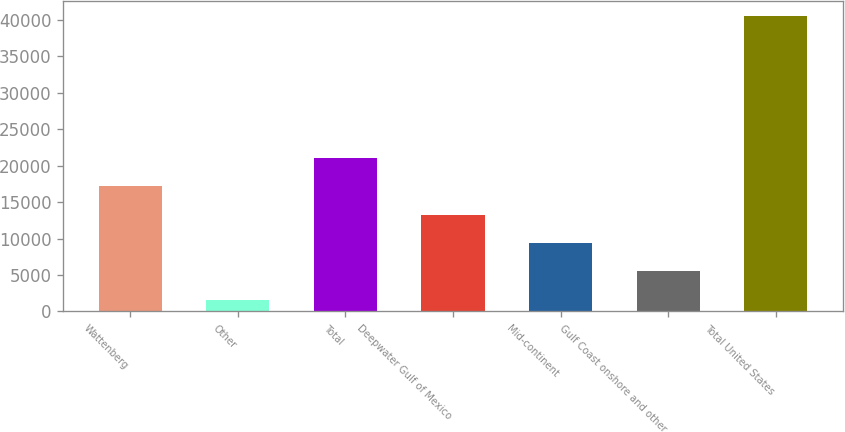<chart> <loc_0><loc_0><loc_500><loc_500><bar_chart><fcel>Wattenberg<fcel>Other<fcel>Total<fcel>Deepwater Gulf of Mexico<fcel>Mid-continent<fcel>Gulf Coast onshore and other<fcel>Total United States<nl><fcel>17181.6<fcel>1618<fcel>21072.5<fcel>13290.7<fcel>9399.8<fcel>5508.9<fcel>40527<nl></chart> 